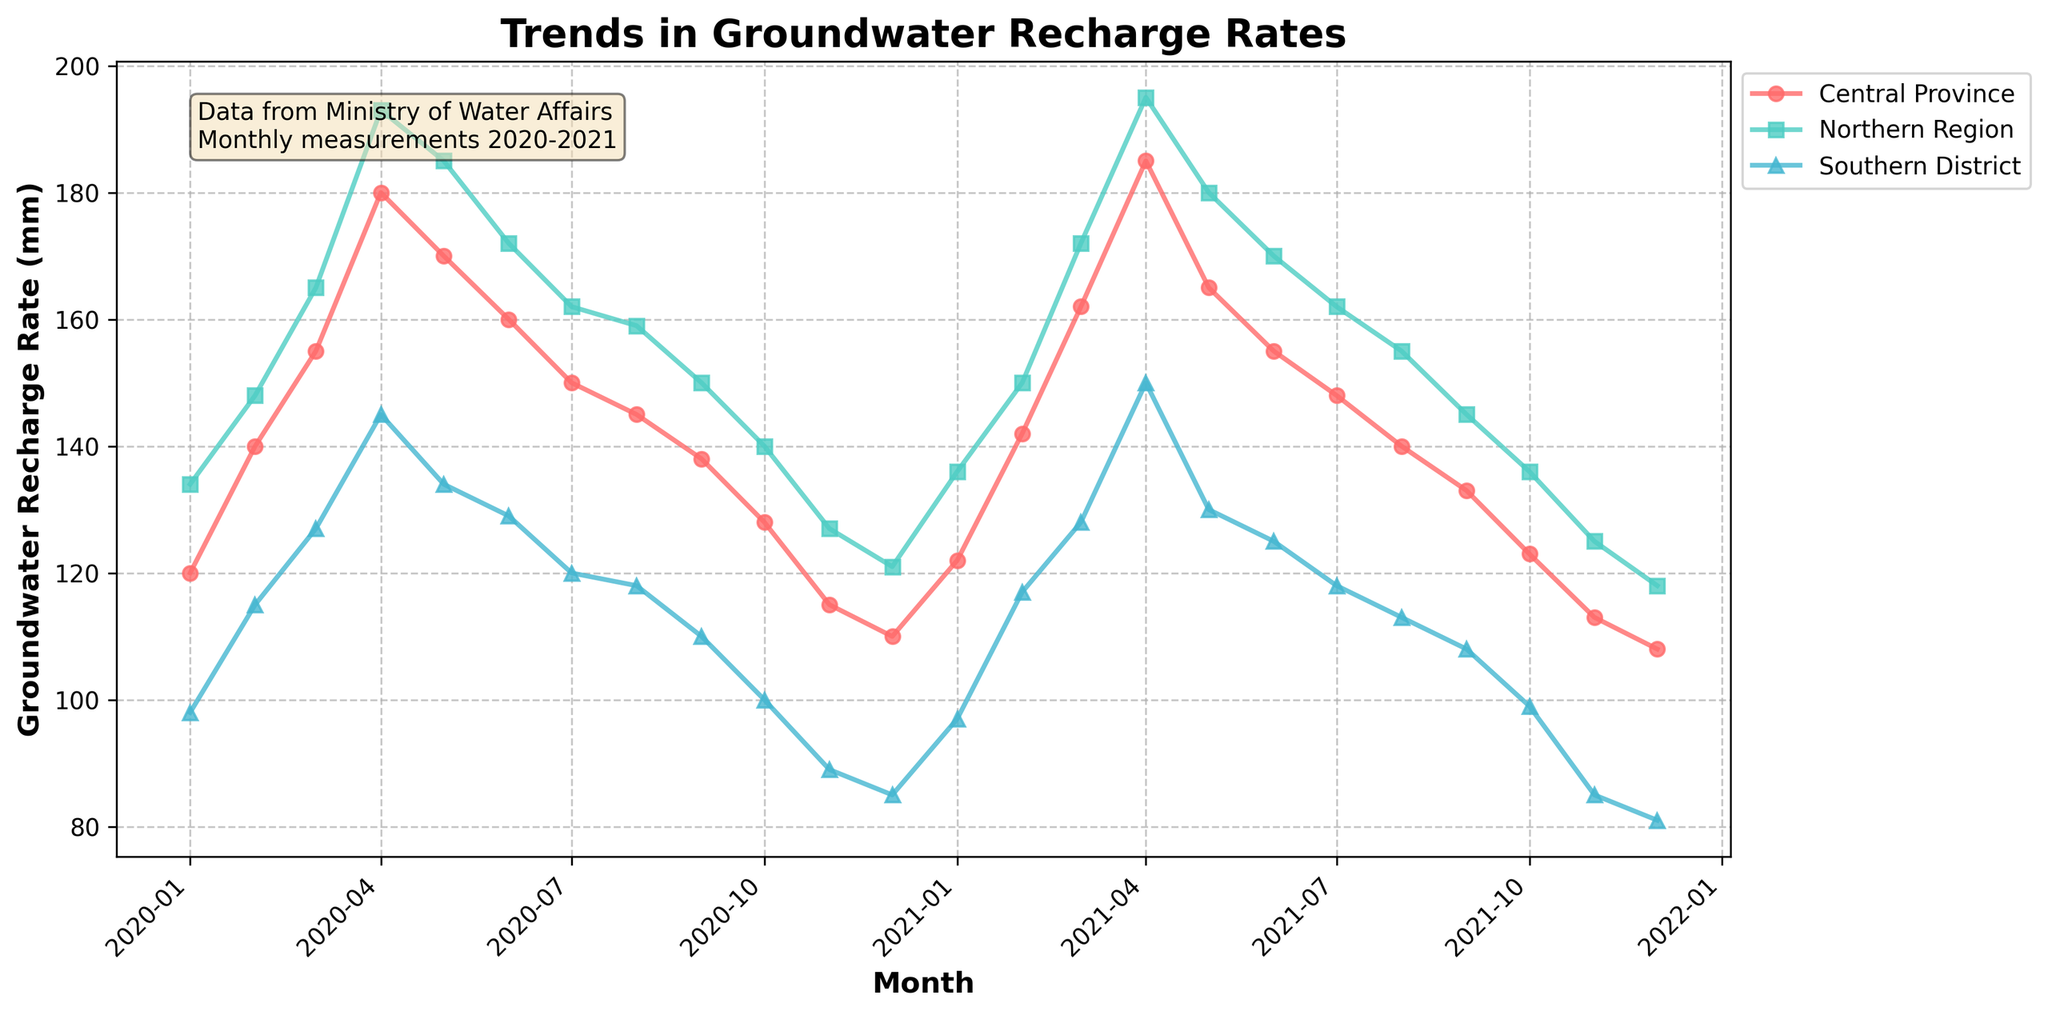what is the title of this plot? The title is usually located at the top of the plot and describes what the plot represents. It helps identify the main theme of the figure. In this plot, it's titled "Trends in Groundwater Recharge Rates," indicating it shows changes in groundwater recharge rates over time.
Answer: Trends in Groundwater Recharge Rates how many regions are represented in the plot? The plot legend, commonly found on the side or bottom, lists all the regions. Here, it shows three regions: Central Province, Northern Region, and Southern District.
Answer: 3 which region had the highest groundwater recharge rate in April 2021? To find this, look at the data points for April 2021 across all regions. The Northern Region has the highest value in April 2021.
Answer: Northern Region what is the average groundwater recharge rate for the Southern District in 2020? To calculate this, identify all the Southern District values in 2020, add them up, and divide by the number of data points. The values are: 98, 115, 127, 145, 134, 129, 120, 118, 110, 100, 89, 85. The sum is 1370, and there are 12 months, so the average is 1370/12.
Answer: 114.2 mm which month showed the lowest groundwater recharge rate in the Central Province? Inspect the Central Province trend line, lowest value is in December 2021.
Answer: December 2021 is there a general trend in the groundwater recharge rate for the Northern Region from 2020 to 2021? Observing the Northern Region's line shows an upward trend from January 2020 to April 2021, peaking, before a gradual decline toward December 2021.
Answer: It increased, peaked, then declined how does the groundwater recharge rate in January 2020 compare across the regions? The values for January 2020 are: Central Province (120), Northern Region (134), and Southern District (98). The Northern Region has the highest, followed by Central Province and Southern District.
Answer: Northern > Central > Southern what was the groundwater recharge rate difference between Northern Region and Central Province in April 2020? The values in April 2020 are: Northern Region (193) and Central Province (180). The difference is 193 - 180.
Answer: 13 mm compare the trend lines of Central Province and Southern District; what can you infer about their recharge rates? Both trend lines rise to a peak and then gradually fall. Central Province generally maintains higher rates compared to Southern District but follows a similar pattern.
Answer: Central Province generally higher yet similar trends 